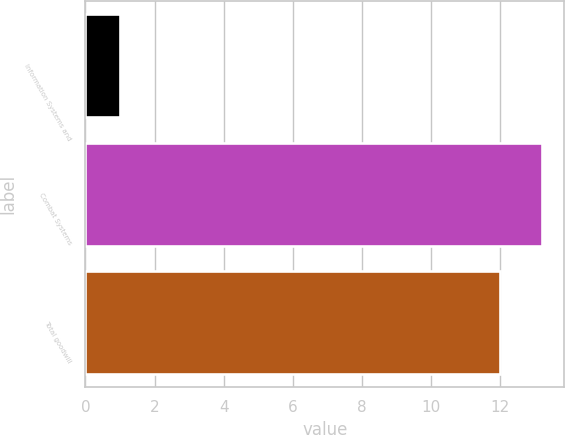<chart> <loc_0><loc_0><loc_500><loc_500><bar_chart><fcel>Information Systems and<fcel>Combat Systems<fcel>Total goodwill<nl><fcel>1<fcel>13.2<fcel>12<nl></chart> 